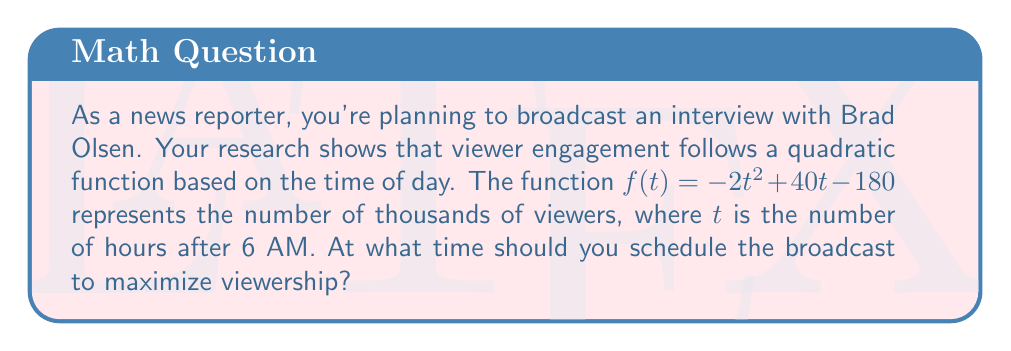Could you help me with this problem? To solve this problem, we need to find the maximum of the quadratic function. The steps are as follows:

1) The quadratic function is in the form $f(t) = -2t^2 + 40t - 180$, where $a = -2$, $b = 40$, and $c = -180$.

2) For a quadratic function $f(t) = at^2 + bt + c$, the t-coordinate of the vertex (which gives the maximum when $a < 0$) is given by the formula:

   $$t = -\frac{b}{2a}$$

3) Substituting our values:

   $$t = -\frac{40}{2(-2)} = -\frac{40}{-4} = 10$$

4) This means the maximum viewership occurs 10 hours after 6 AM, which is 4 PM.

5) To verify, we can calculate the y-coordinate of the vertex:

   $$f(10) = -2(10)^2 + 40(10) - 180$$
   $$= -200 + 400 - 180 = 20$$

   This means the maximum viewership is 20,000 viewers at 4 PM.
Answer: The optimal time for the broadcast is 4 PM, which is 10 hours after 6 AM. 